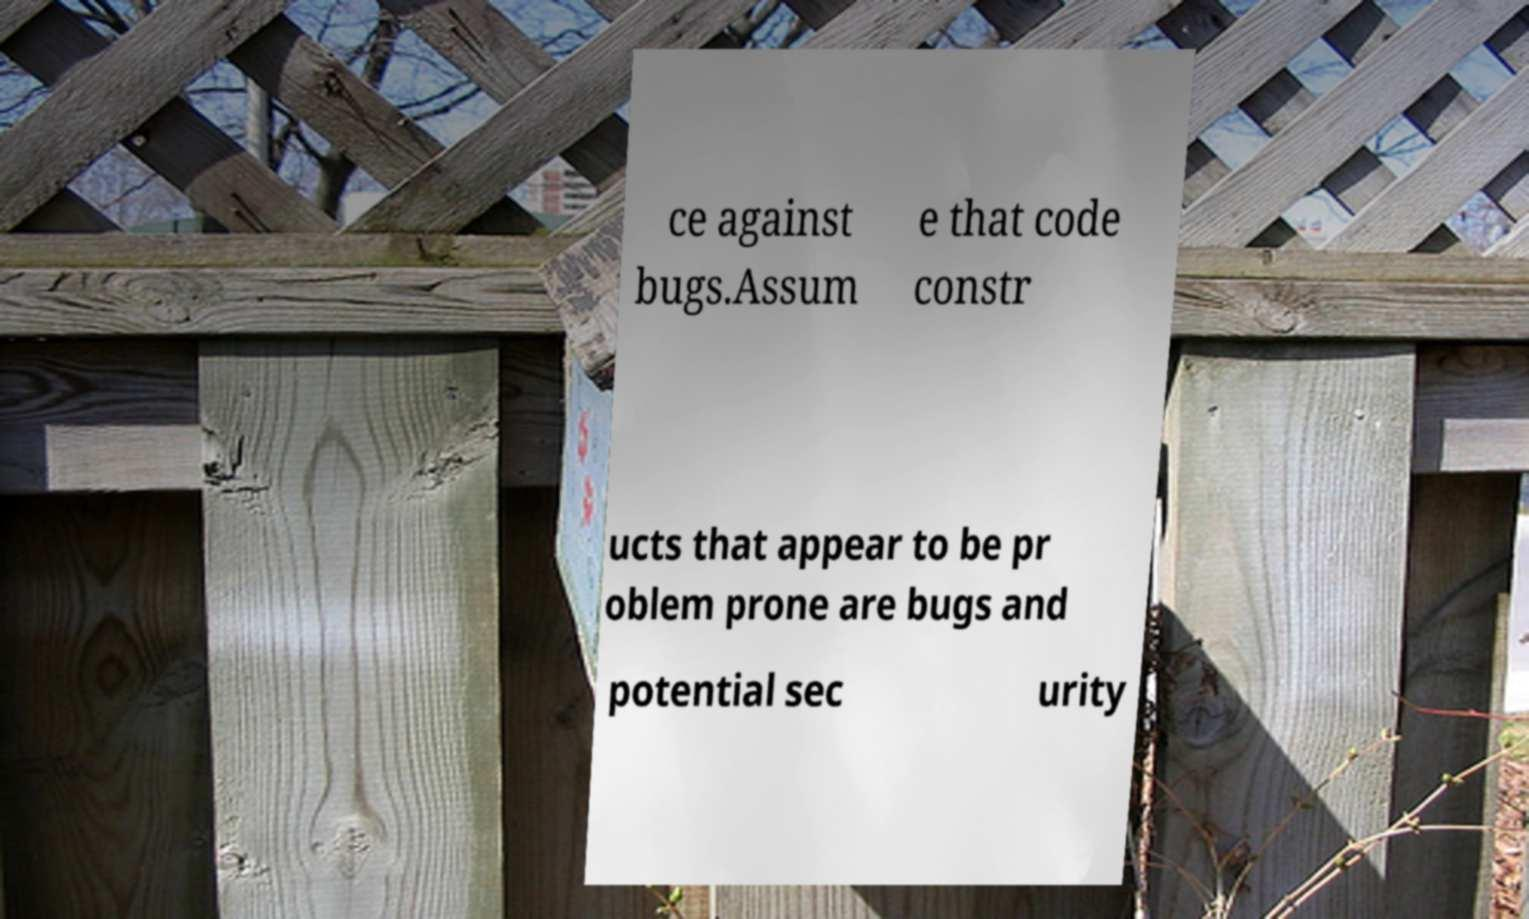Please identify and transcribe the text found in this image. ce against bugs.Assum e that code constr ucts that appear to be pr oblem prone are bugs and potential sec urity 